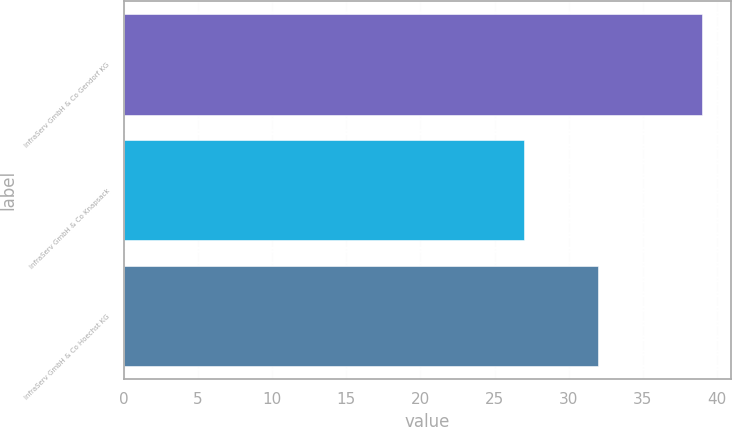Convert chart to OTSL. <chart><loc_0><loc_0><loc_500><loc_500><bar_chart><fcel>InfraServ GmbH & Co Gendorf KG<fcel>InfraServ GmbH & Co Knapsack<fcel>InfraServ GmbH & Co Hoechst KG<nl><fcel>39<fcel>27<fcel>32<nl></chart> 